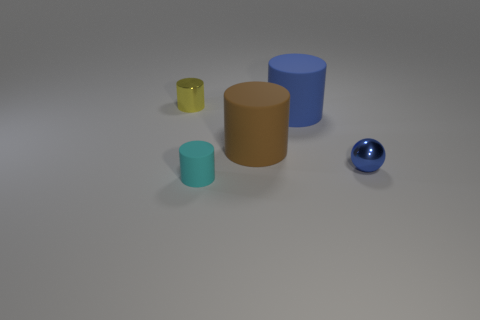Add 3 small balls. How many objects exist? 8 Subtract all cylinders. How many objects are left? 1 Add 4 tiny metallic spheres. How many tiny metallic spheres exist? 5 Subtract 0 purple spheres. How many objects are left? 5 Subtract all small gray matte cylinders. Subtract all blue metallic things. How many objects are left? 4 Add 1 small yellow cylinders. How many small yellow cylinders are left? 2 